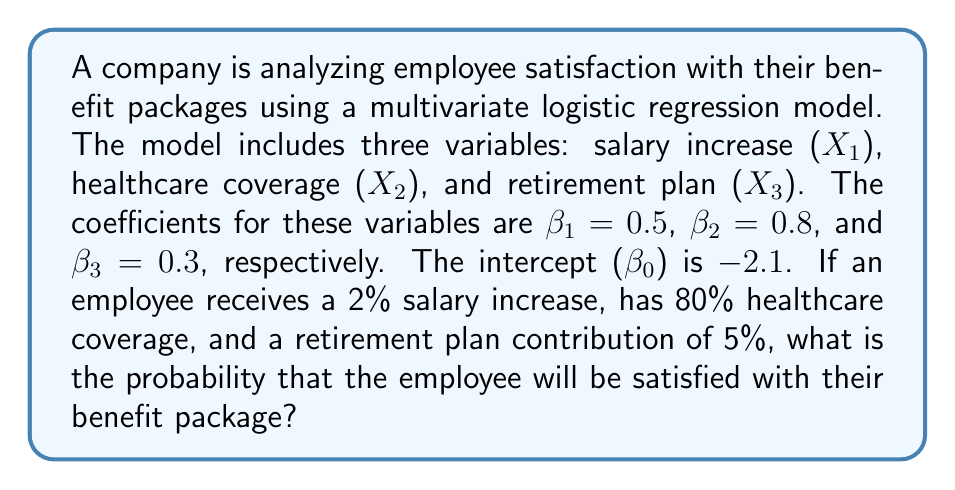Could you help me with this problem? To solve this problem, we'll use the logistic regression model to calculate the probability of employee satisfaction. The steps are as follows:

1) The logistic regression model is given by:

   $$P(Y=1) = \frac{1}{1 + e^{-z}}$$

   where $z = β₀ + β₁X₁ + β₂X₂ + β₃X₃$

2) We're given:
   - β₀ = -2.1
   - β₁ = 0.5, X₁ = 2 (2% salary increase)
   - β₂ = 0.8, X₂ = 80 (80% healthcare coverage)
   - β₃ = 0.3, X₃ = 5 (5% retirement plan contribution)

3) Let's calculate z:
   $$z = -2.1 + 0.5(2) + 0.8(80) + 0.3(5)$$
   $$z = -2.1 + 1 + 64 + 1.5$$
   $$z = 64.4$$

4) Now we can calculate the probability:
   $$P(Y=1) = \frac{1}{1 + e^{-64.4}}$$

5) Using a calculator or computer (as this is a very small number):
   $$P(Y=1) ≈ 0.99999999999999999999$$

Therefore, the probability that the employee will be satisfied with their benefit package is approximately 1 or 100%.
Answer: $\approx 1$ or 100% 